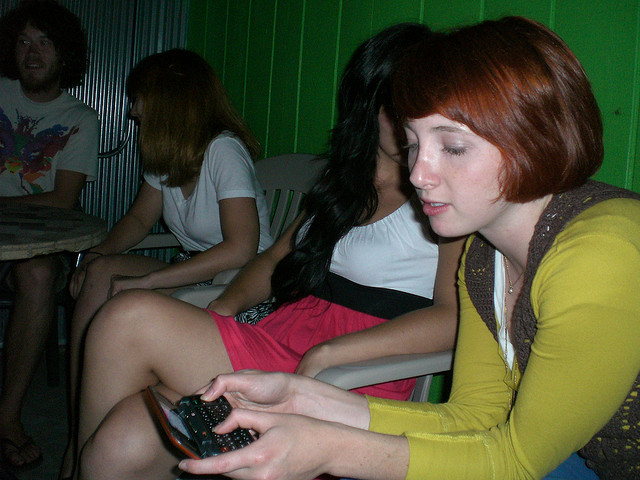<image>What game system is he playing on? I am not sure what game system he is playing on. It could be a phone or an iPad. What game system is she playing with? I am not sure. It can be a cell phone, gameboy, nokia, blackberry or nintendo. What gaming console are they using? I am not sure what gaming console they are using. It could be a phone, Nintendo DS, or Gameboy. What color are the eyes of the girl in glasses? It's unknown what color the eyes of the girl in glasses are. What game system is he playing on? I don't know what game system he is playing on. It can be a phone, cell phone, or iPad. What game system is she playing with? I don't know what game system she is playing with. It can be either a cell phone, phone, gameboy, nokia, blackberry, nintendo lite, or nintendo. What color are the eyes of the girl in glasses? It is unknown what color are the eyes of the girl in glasses. What gaming console are they using? I am not sure what gaming console they are using. It can be seen 'phone', 'nintendo', 'ds', 'gameboy' or 'none'. 